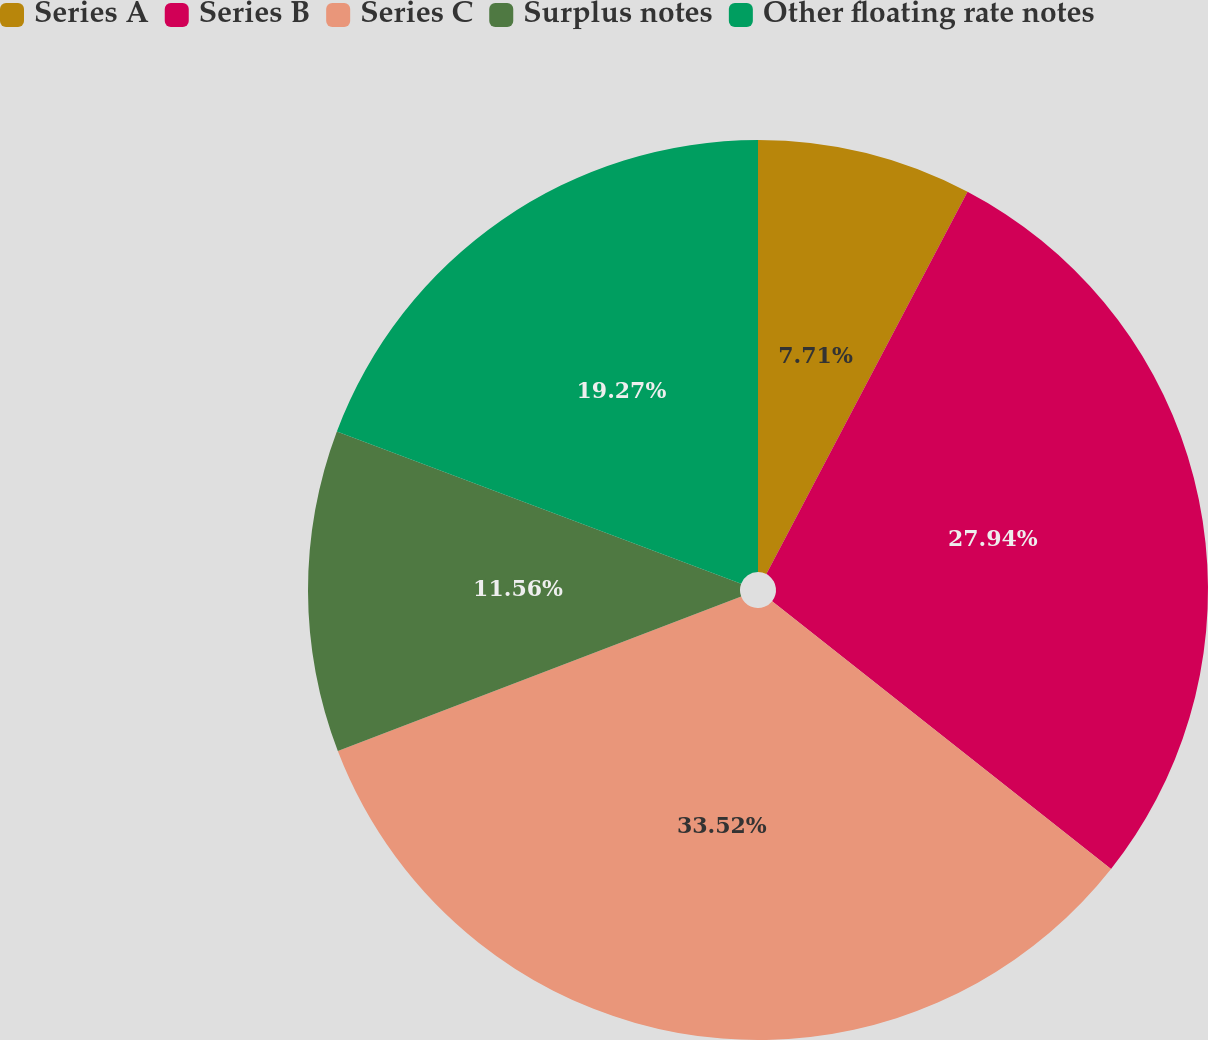<chart> <loc_0><loc_0><loc_500><loc_500><pie_chart><fcel>Series A<fcel>Series B<fcel>Series C<fcel>Surplus notes<fcel>Other floating rate notes<nl><fcel>7.71%<fcel>27.94%<fcel>33.53%<fcel>11.56%<fcel>19.27%<nl></chart> 